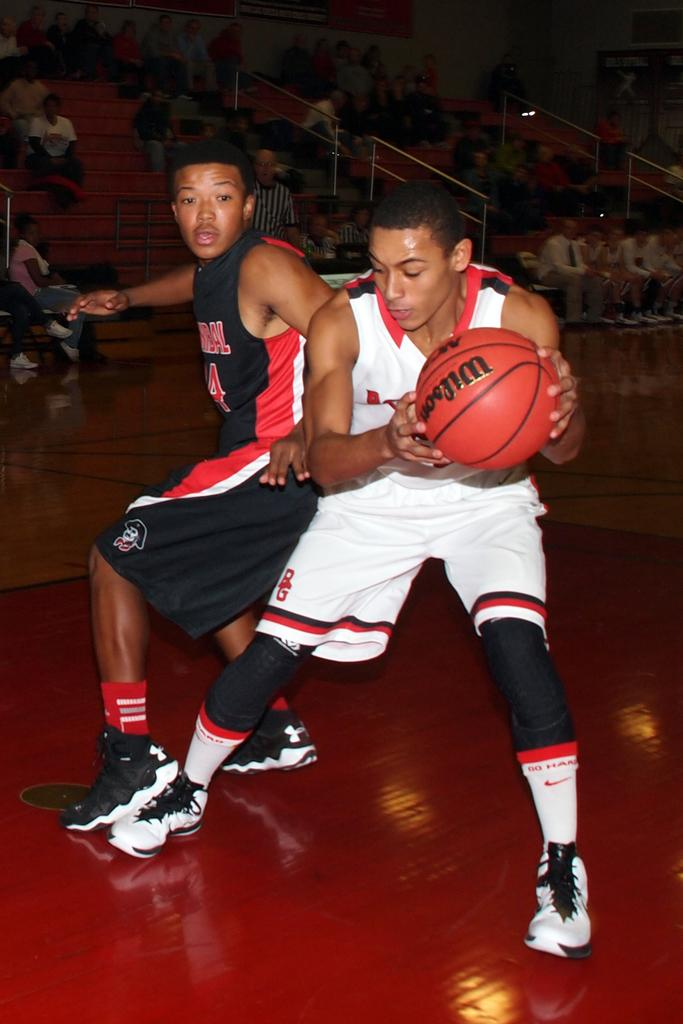<image>
Render a clear and concise summary of the photo. Two basketball players are trying to get the Wilson basketball. 